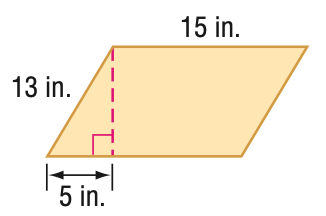Answer the mathemtical geometry problem and directly provide the correct option letter.
Question: Find the perimeter of the parallelogram. Round to the nearest tenth if necessary.
Choices: A: 56 B: 58 C: 60 D: 62 A 